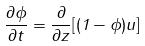Convert formula to latex. <formula><loc_0><loc_0><loc_500><loc_500>\frac { \partial \phi } { \partial t } = \frac { \partial } { \partial z } [ ( 1 - \phi ) u ]</formula> 